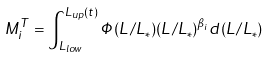Convert formula to latex. <formula><loc_0><loc_0><loc_500><loc_500>M _ { i } ^ { T } = \int _ { L _ { l o w } } ^ { L _ { u p } ( t ) } \Phi ( L / L _ { * } ) ( L / L _ { * } ) ^ { \beta _ { i } } d ( L / L _ { * } )</formula> 